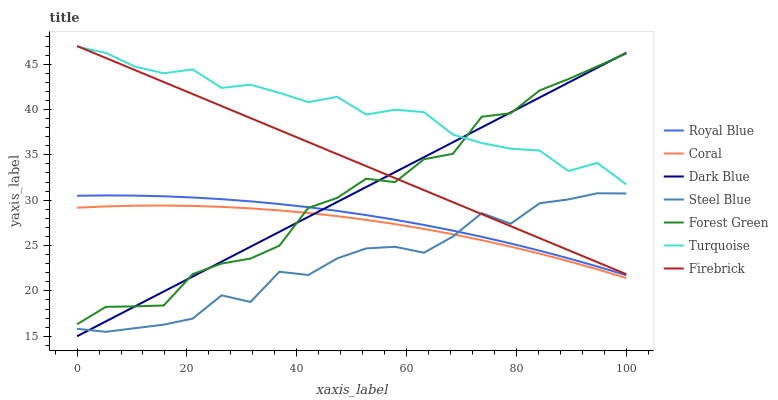Does Steel Blue have the minimum area under the curve?
Answer yes or no. Yes. Does Turquoise have the maximum area under the curve?
Answer yes or no. Yes. Does Dark Blue have the minimum area under the curve?
Answer yes or no. No. Does Dark Blue have the maximum area under the curve?
Answer yes or no. No. Is Dark Blue the smoothest?
Answer yes or no. Yes. Is Forest Green the roughest?
Answer yes or no. Yes. Is Coral the smoothest?
Answer yes or no. No. Is Coral the roughest?
Answer yes or no. No. Does Dark Blue have the lowest value?
Answer yes or no. Yes. Does Coral have the lowest value?
Answer yes or no. No. Does Firebrick have the highest value?
Answer yes or no. Yes. Does Dark Blue have the highest value?
Answer yes or no. No. Is Steel Blue less than Forest Green?
Answer yes or no. Yes. Is Turquoise greater than Steel Blue?
Answer yes or no. Yes. Does Royal Blue intersect Dark Blue?
Answer yes or no. Yes. Is Royal Blue less than Dark Blue?
Answer yes or no. No. Is Royal Blue greater than Dark Blue?
Answer yes or no. No. Does Steel Blue intersect Forest Green?
Answer yes or no. No. 